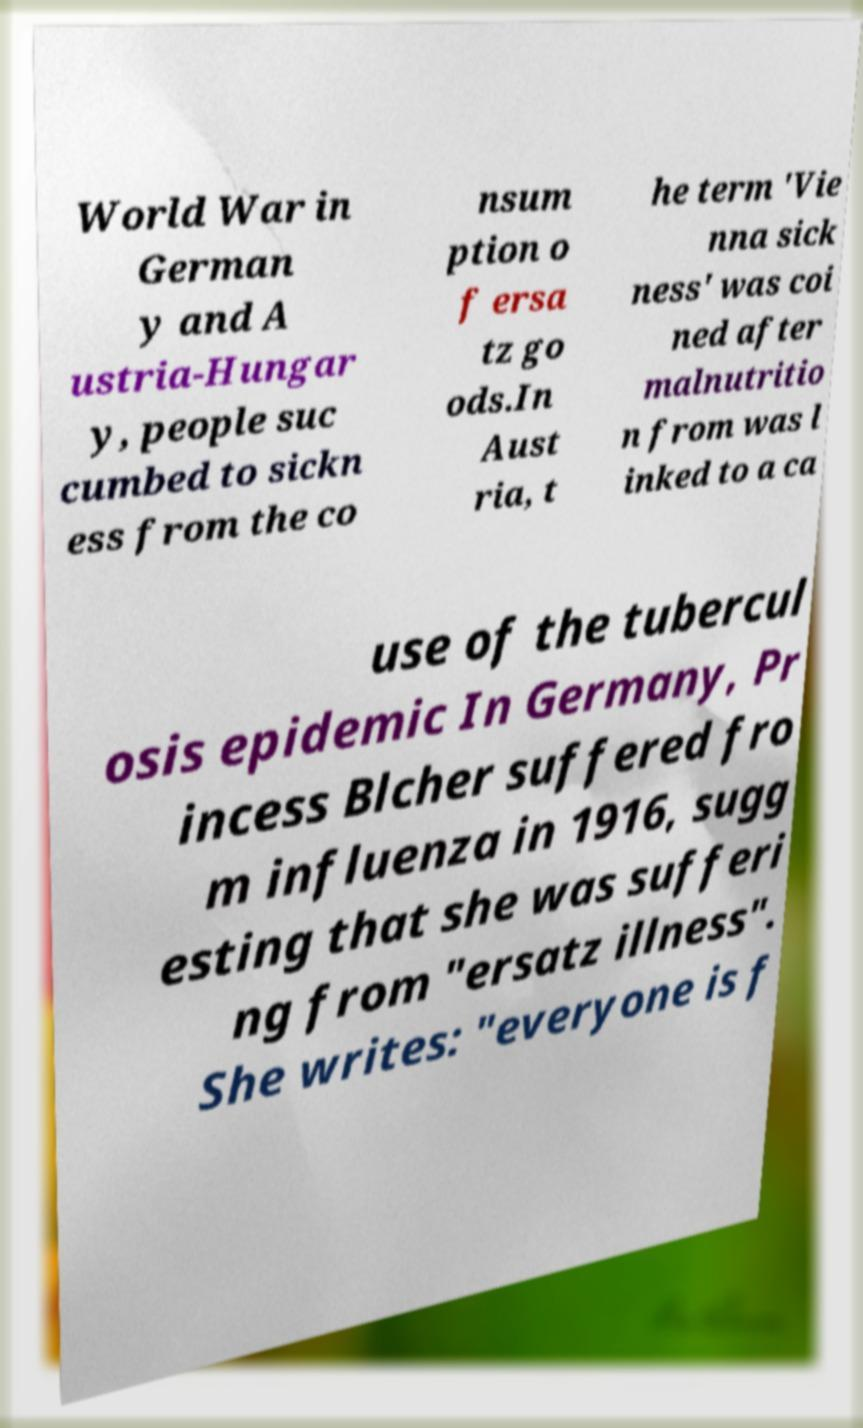Could you extract and type out the text from this image? World War in German y and A ustria-Hungar y, people suc cumbed to sickn ess from the co nsum ption o f ersa tz go ods.In Aust ria, t he term 'Vie nna sick ness' was coi ned after malnutritio n from was l inked to a ca use of the tubercul osis epidemic In Germany, Pr incess Blcher suffered fro m influenza in 1916, sugg esting that she was sufferi ng from "ersatz illness". She writes: "everyone is f 